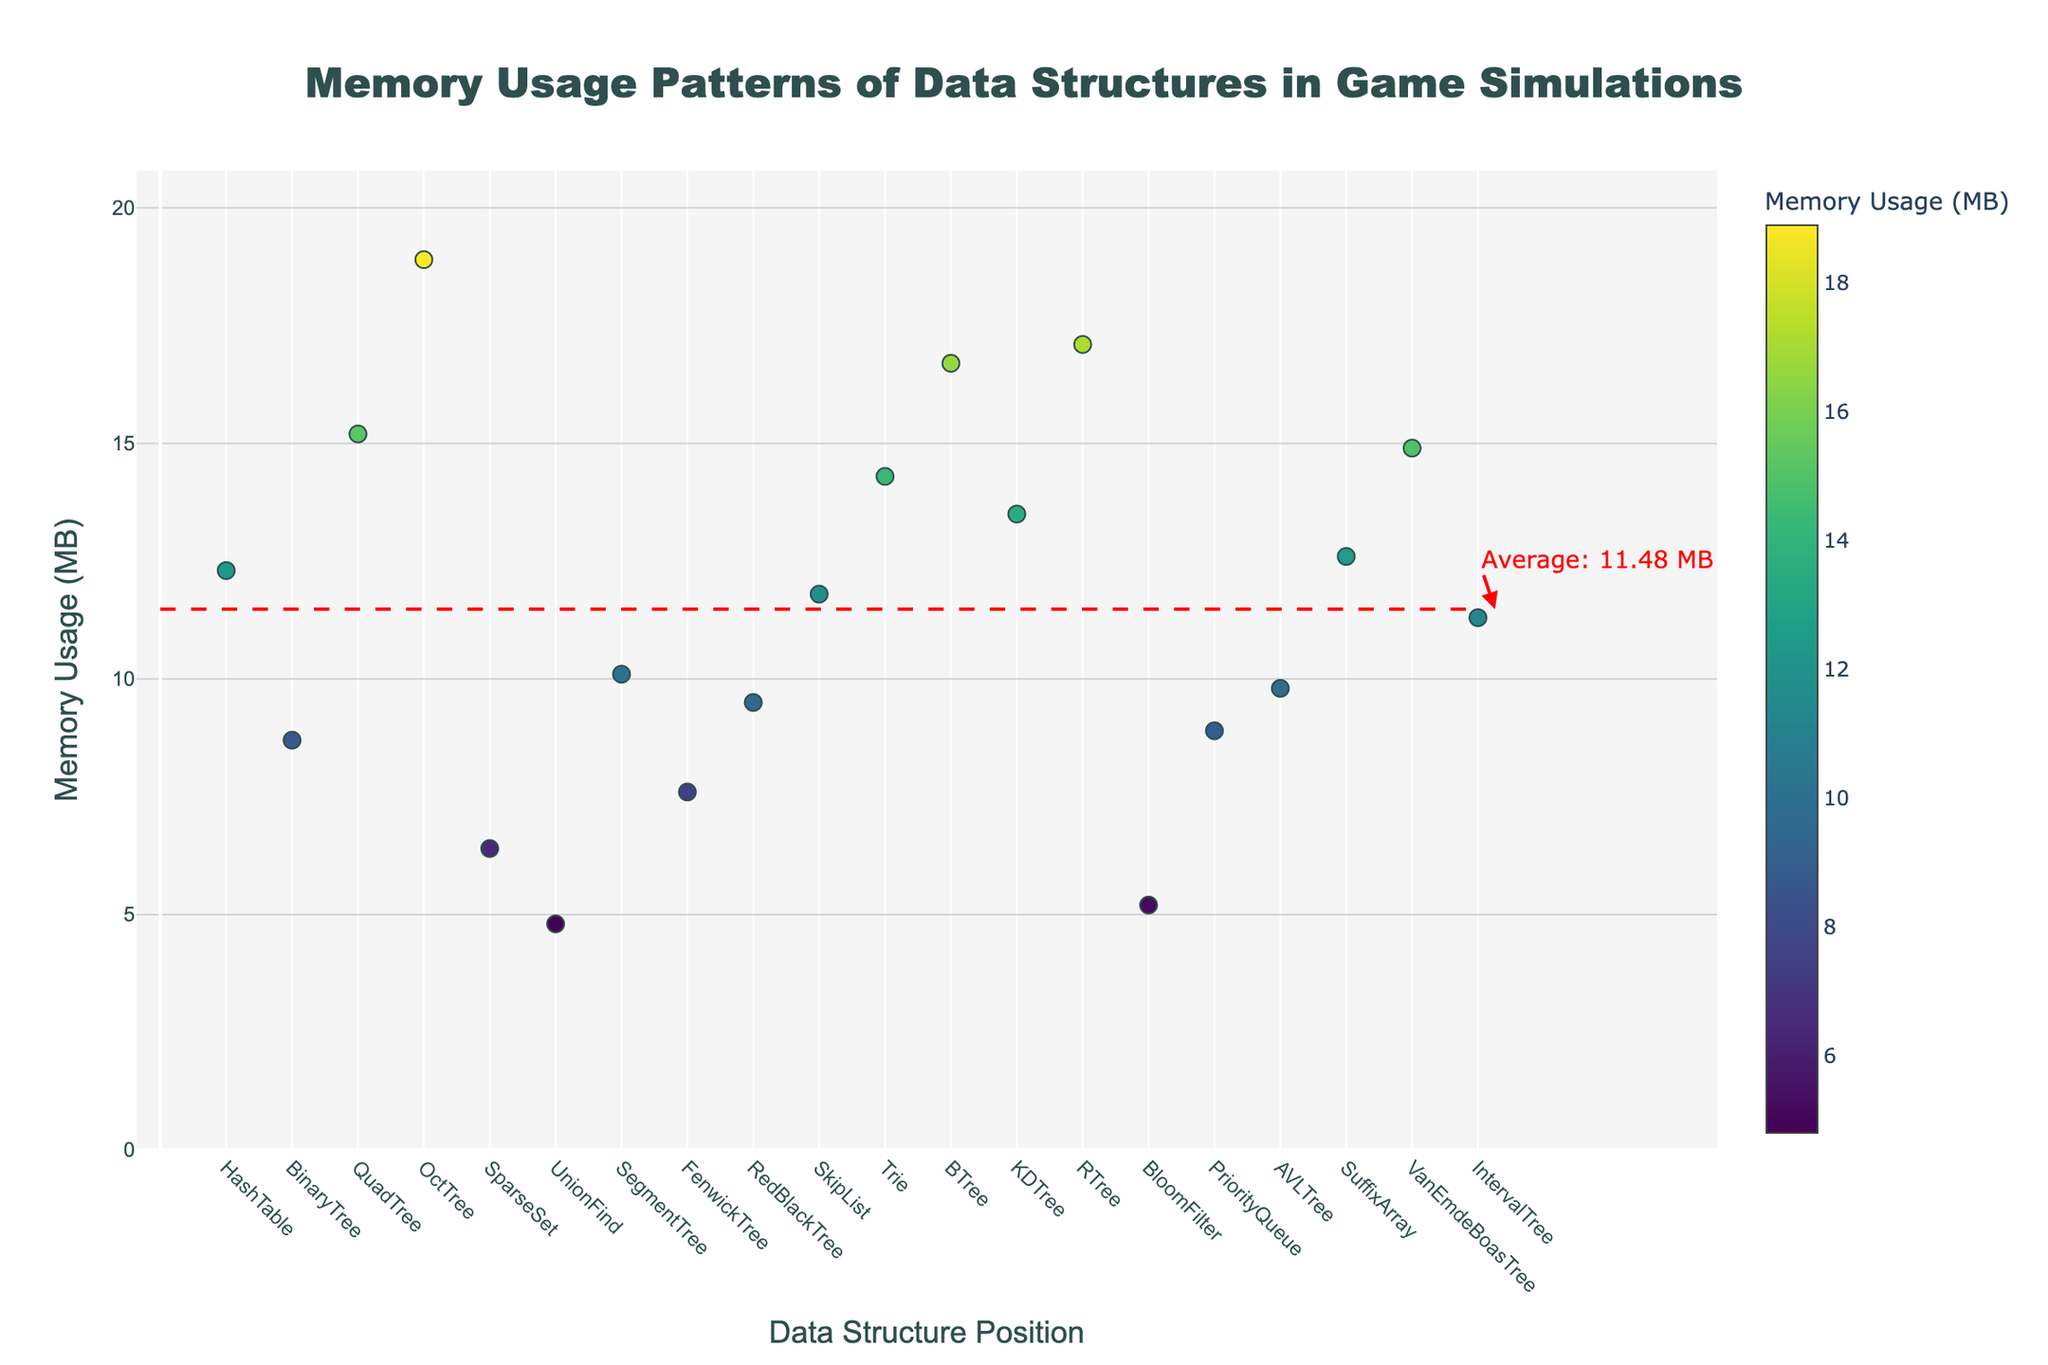How many types of data structures are analyzed in this plot? Count the number of unique data structures listed along the x-axis.
Answer: 20 What is the title of the plot? The title is located at the top center of the plot.
Answer: Memory Usage Patterns of Data Structures in Game Simulations Which data structure has the highest memory usage? Look for the data point with the highest y-value, then refer to the corresponding x-axis label.
Answer: OctTree What is the average memory usage for these data structures? This value is indicated by the horizontal red dashed line and its annotation.
Answer: 11.43 MB Which data structure has the lowest memory usage? Look for the data point with the lowest y-value, then refer to the corresponding x-axis label.
Answer: UnionFind Is there any data structure with memory usage exactly at the average? Compare each data point to the average line to see if any match the average memory usage.
Answer: No How does the memory usage of SuffixArray compare to that of RedBlackTree? Note the y-values for SuffixArray and RedBlackTree and compare them.
Answer: SuffixArray has higher memory usage than RedBlackTree What is the difference in memory usage between AVLTree and Trie? Find the y-values for AVLTree and Trie, then subtract the smaller from the larger.
Answer: 4.5 MB How many data structures have memory usage greater than 15 MB? Count the data points with y-values greater than 15 MB.
Answer: 5 Which data structure closest to the average memory usage, but not exactly at the average? Identify the data points around the average line and find the one with the smallest difference from the average.
Answer: IntervalTree 